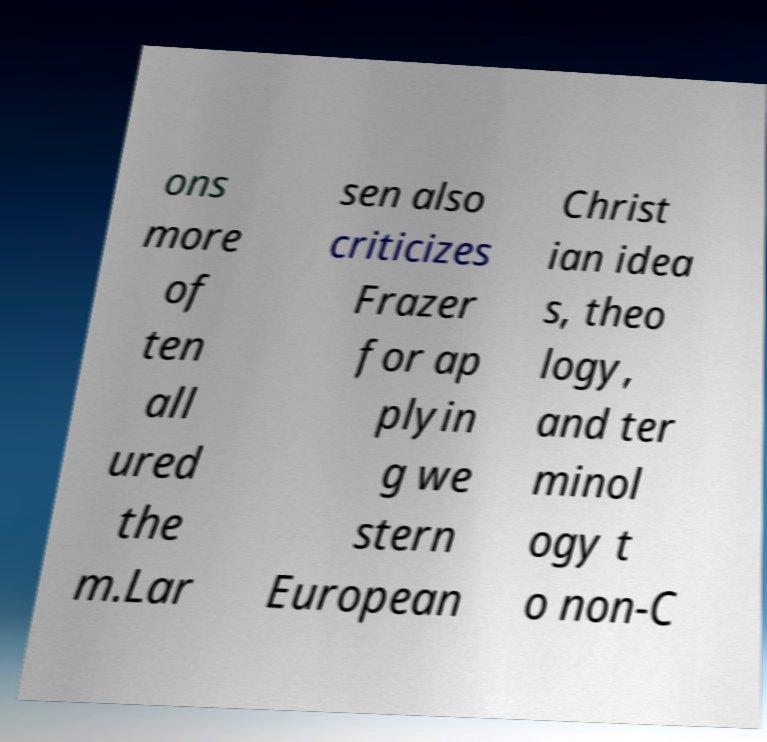I need the written content from this picture converted into text. Can you do that? ons more of ten all ured the m.Lar sen also criticizes Frazer for ap plyin g we stern European Christ ian idea s, theo logy, and ter minol ogy t o non-C 